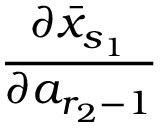<formula> <loc_0><loc_0><loc_500><loc_500>\frac { \partial \bar { x } _ { s _ { 1 } } } { \partial a _ { r _ { 2 } - 1 } }</formula> 